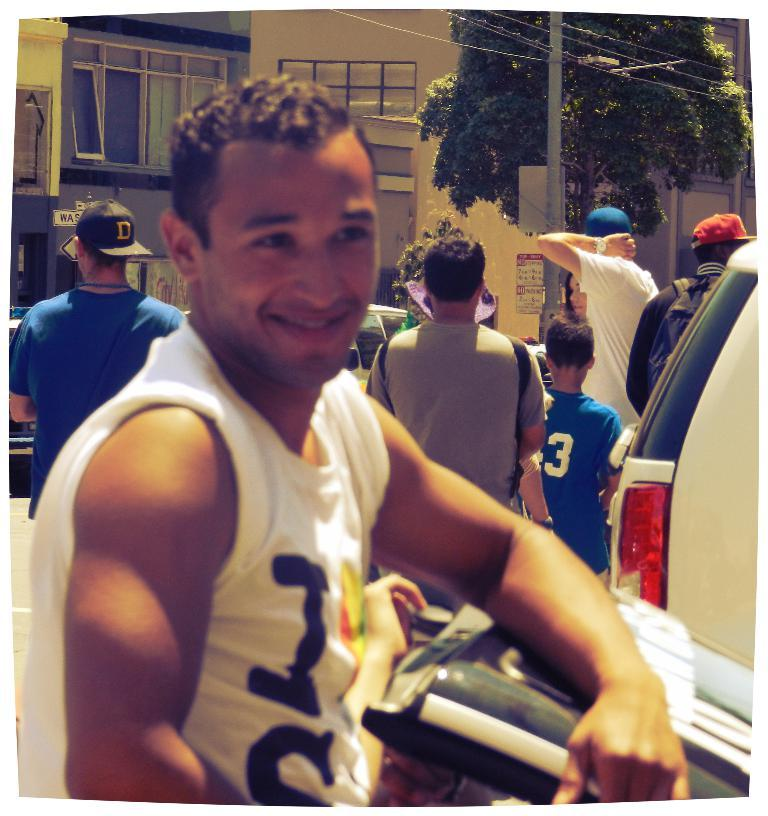What is the main subject of the image? There is a person standing on the road in the image. Can you describe the background of the image? In the background of the image, there are persons, a car, a tree, a pole, wires, and buildings. How many people can be seen in the image? There is one person standing on the road and at least one person visible in the background, so there are at least two people in the image. What type of linen is being used to sew a needle in the image? There is no linen or needle present in the image; it features a person standing on the road and various elements in the background. 